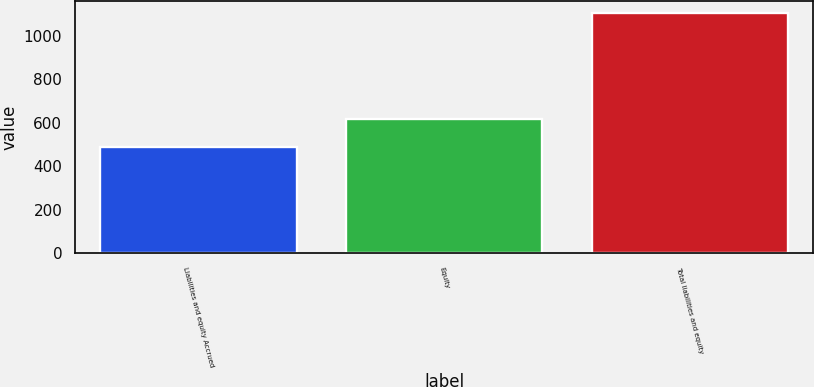Convert chart to OTSL. <chart><loc_0><loc_0><loc_500><loc_500><bar_chart><fcel>Liabilities and equity Accrued<fcel>Equity<fcel>Total liabilities and equity<nl><fcel>487<fcel>619<fcel>1106<nl></chart> 